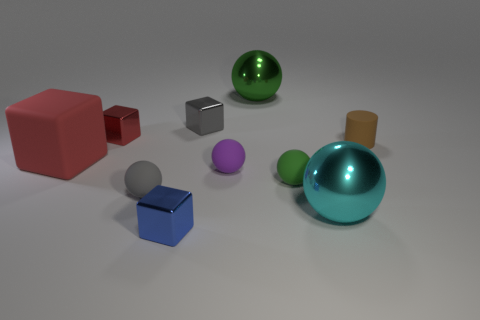Subtract all large cubes. How many cubes are left? 3 Subtract all cyan balls. How many balls are left? 4 Subtract all blue spheres. How many red blocks are left? 2 Subtract 3 blocks. How many blocks are left? 1 Subtract all purple cylinders. Subtract all yellow spheres. How many cylinders are left? 1 Subtract 0 green cylinders. How many objects are left? 10 Subtract all cylinders. How many objects are left? 9 Subtract all green spheres. Subtract all tiny blue cubes. How many objects are left? 7 Add 5 spheres. How many spheres are left? 10 Add 7 red shiny blocks. How many red shiny blocks exist? 8 